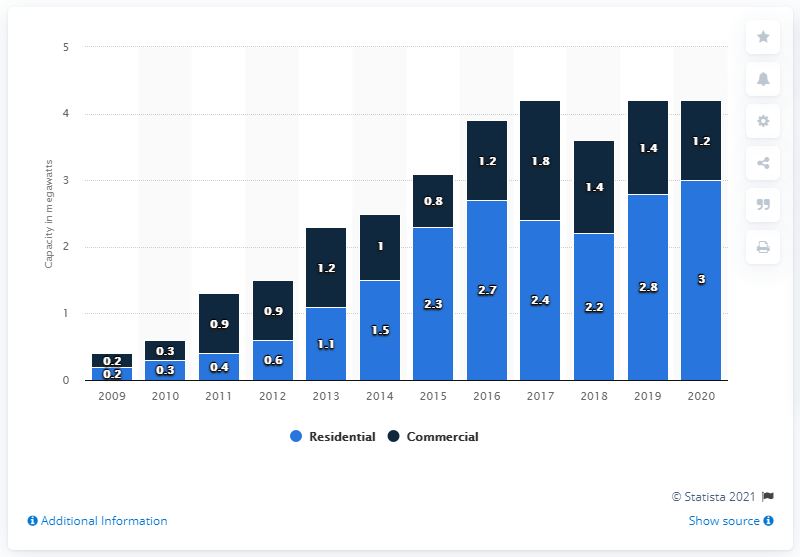Highlight a few significant elements in this photo. In 2014, the residential sector installed a larger capacity of small-scale solar photovoltaic systems than the commercial sector. 